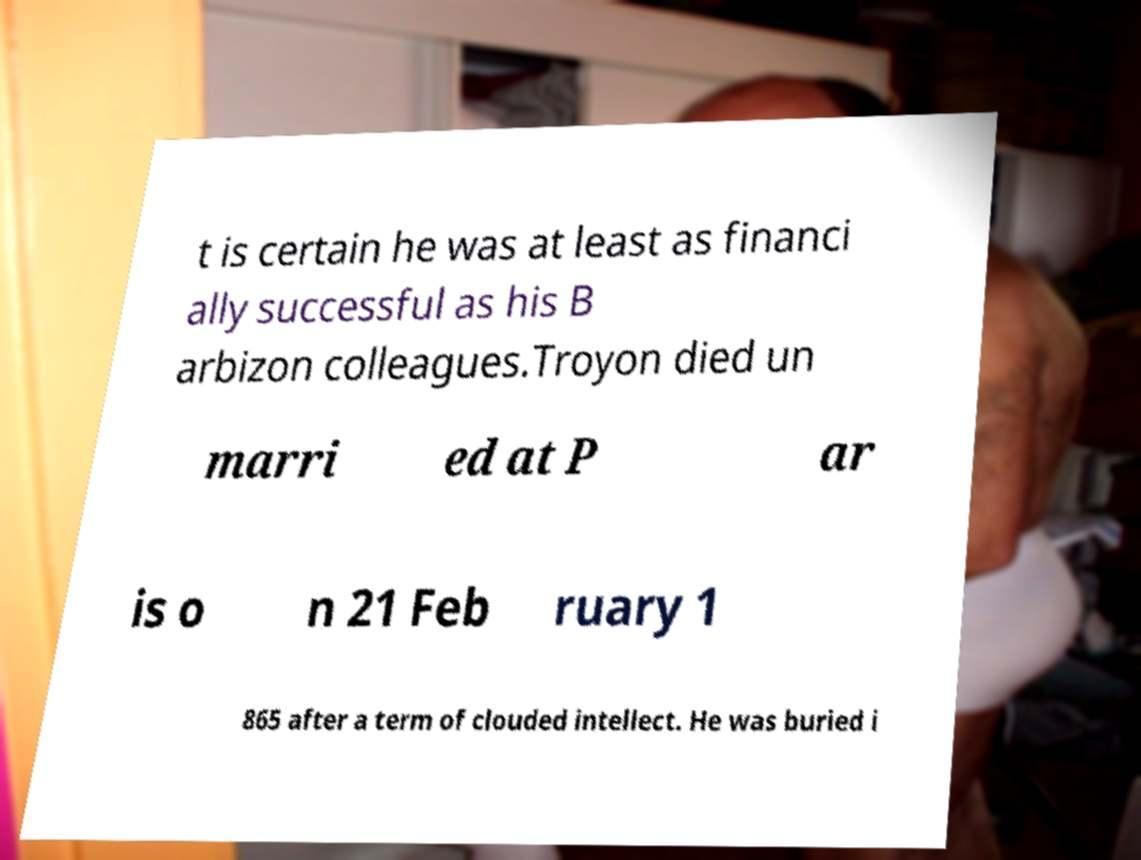Can you accurately transcribe the text from the provided image for me? t is certain he was at least as financi ally successful as his B arbizon colleagues.Troyon died un marri ed at P ar is o n 21 Feb ruary 1 865 after a term of clouded intellect. He was buried i 